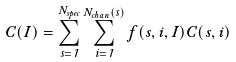Convert formula to latex. <formula><loc_0><loc_0><loc_500><loc_500>C ( I ) = \sum _ { s = 1 } ^ { N _ { s p e c } } \sum _ { i = 1 } ^ { N _ { c h a n } ( s ) } f ( s , i , I ) C ( s , i )</formula> 